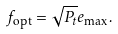<formula> <loc_0><loc_0><loc_500><loc_500>f _ { \text {opt} } = \sqrt { P _ { t } } e _ { \max } .</formula> 